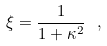Convert formula to latex. <formula><loc_0><loc_0><loc_500><loc_500>\xi = \frac { 1 } { 1 + \kappa ^ { 2 } } \ ,</formula> 